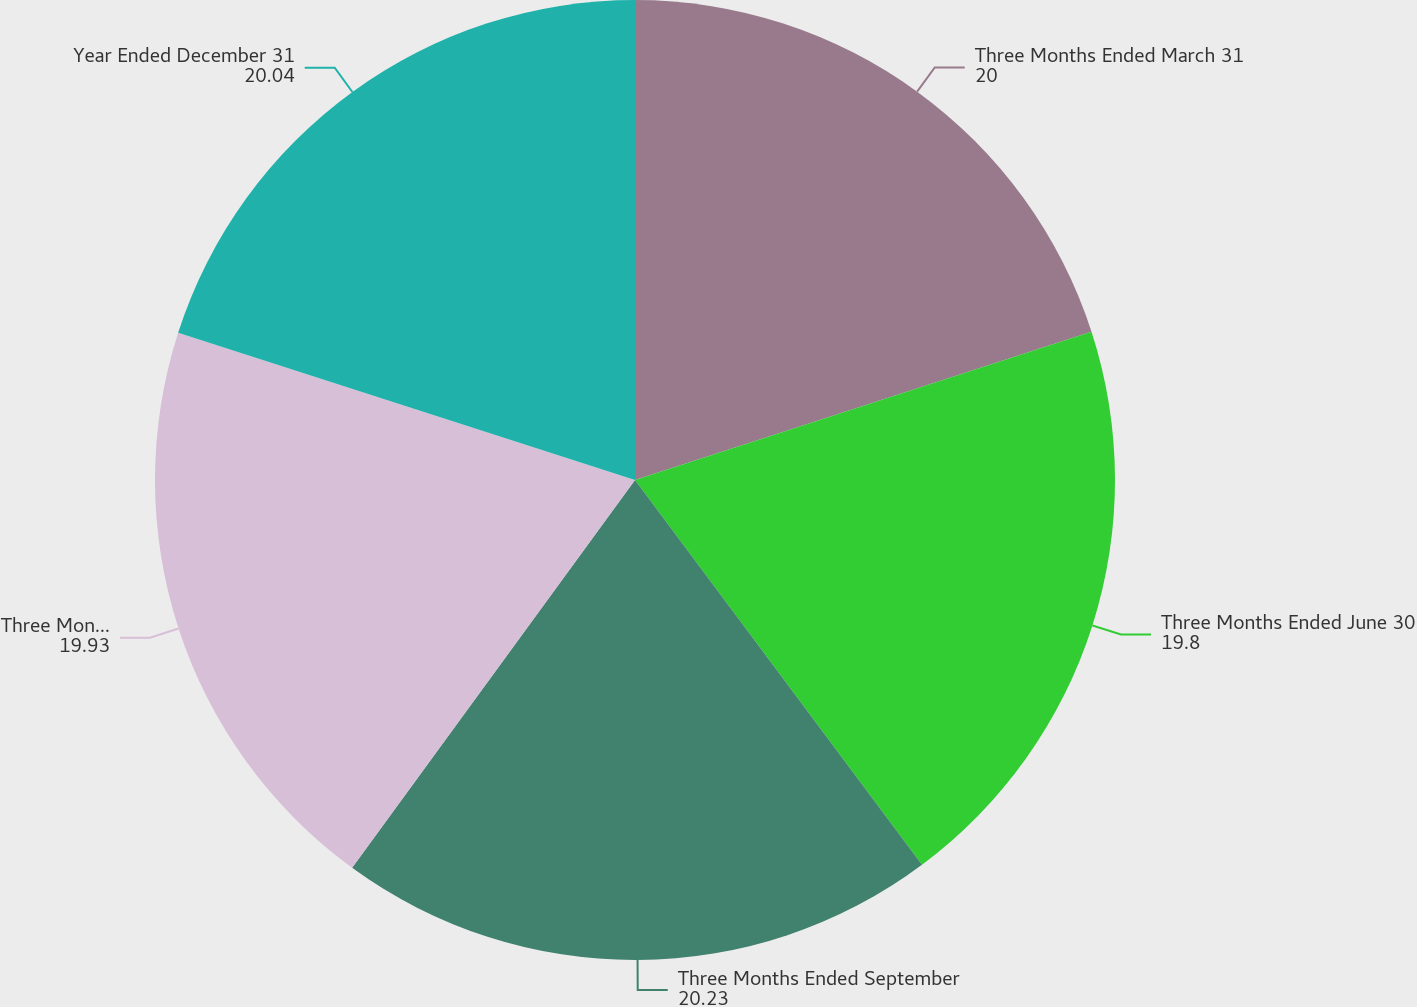<chart> <loc_0><loc_0><loc_500><loc_500><pie_chart><fcel>Three Months Ended March 31<fcel>Three Months Ended June 30<fcel>Three Months Ended September<fcel>Three Months Ended December 31<fcel>Year Ended December 31<nl><fcel>20.0%<fcel>19.8%<fcel>20.23%<fcel>19.93%<fcel>20.04%<nl></chart> 